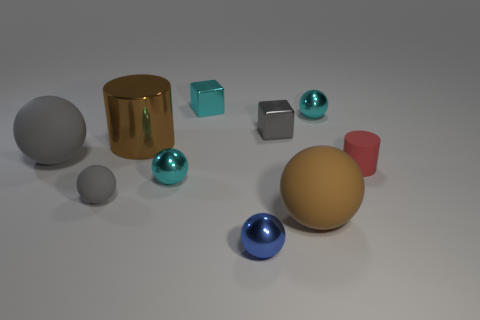What is the color of the big sphere that is in front of the large ball that is to the left of the small blue metallic thing?
Offer a terse response. Brown. Is the color of the big matte ball in front of the large gray ball the same as the big metal cylinder?
Provide a short and direct response. Yes. There is a cylinder that is in front of the big gray thing; what is it made of?
Offer a terse response. Rubber. How big is the metallic cylinder?
Your response must be concise. Large. Are the big gray ball on the left side of the metallic cylinder and the small blue object made of the same material?
Your response must be concise. No. What number of big gray cylinders are there?
Offer a very short reply. 0. What number of objects are either large brown matte objects or tiny gray balls?
Offer a terse response. 2. What number of shiny things are to the right of the tiny cyan sphere that is left of the cyan sphere right of the tiny blue metallic ball?
Provide a succinct answer. 4. Are there any other things that are the same color as the rubber cylinder?
Provide a short and direct response. No. Is the color of the matte ball that is behind the red cylinder the same as the small matte thing right of the brown rubber sphere?
Your answer should be very brief. No. 